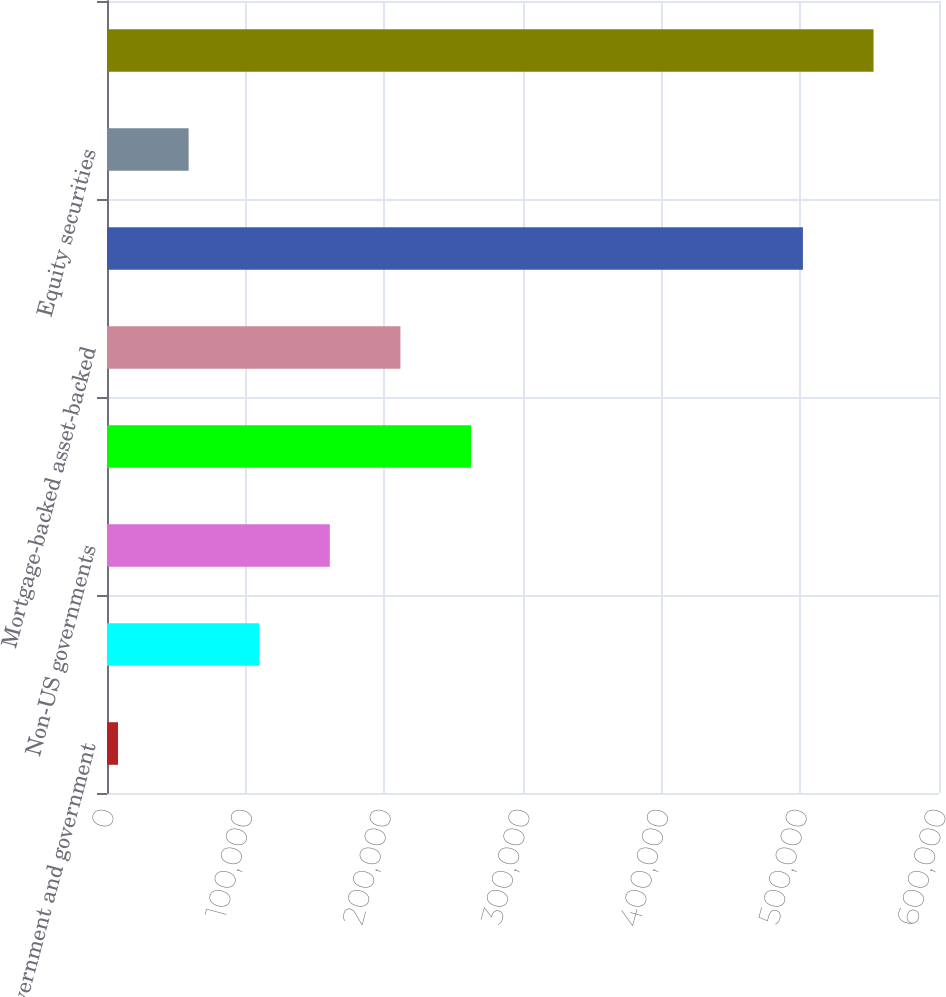Convert chart. <chart><loc_0><loc_0><loc_500><loc_500><bar_chart><fcel>US government and government<fcel>Obligations of states<fcel>Non-US governments<fcel>Corporate debt<fcel>Mortgage-backed asset-backed<fcel>Total bonds<fcel>Equity securities<fcel>Total<nl><fcel>7956<fcel>109776<fcel>160687<fcel>262507<fcel>211597<fcel>501870<fcel>58866.2<fcel>552780<nl></chart> 